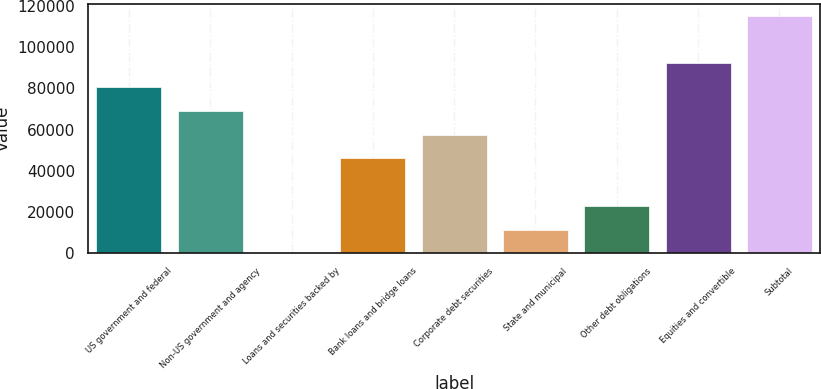<chart> <loc_0><loc_0><loc_500><loc_500><bar_chart><fcel>US government and federal<fcel>Non-US government and agency<fcel>Loans and securities backed by<fcel>Bank loans and bridge loans<fcel>Corporate debt securities<fcel>State and municipal<fcel>Other debt obligations<fcel>Equities and convertible<fcel>Subtotal<nl><fcel>80674.2<fcel>69149.6<fcel>2<fcel>46100.4<fcel>57625<fcel>11526.6<fcel>23051.2<fcel>92198.8<fcel>115248<nl></chart> 